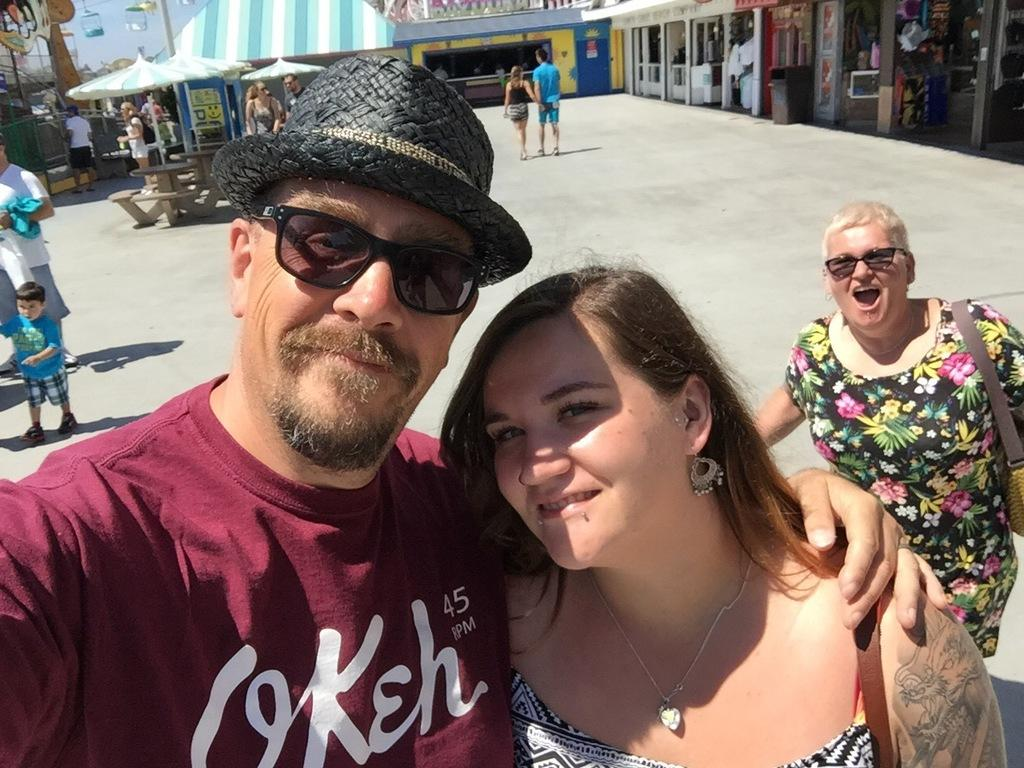What is the man in the image wearing? The man is wearing a t-shirt. Who is standing beside the man? A woman is standing beside the man. What are two people doing in the middle of the image? Two persons are walking in the middle of the image. What can be seen on the right side of the image? There are stores on the right side of the image. What is the texture of the beds in the image? There are no beds present in the image. 